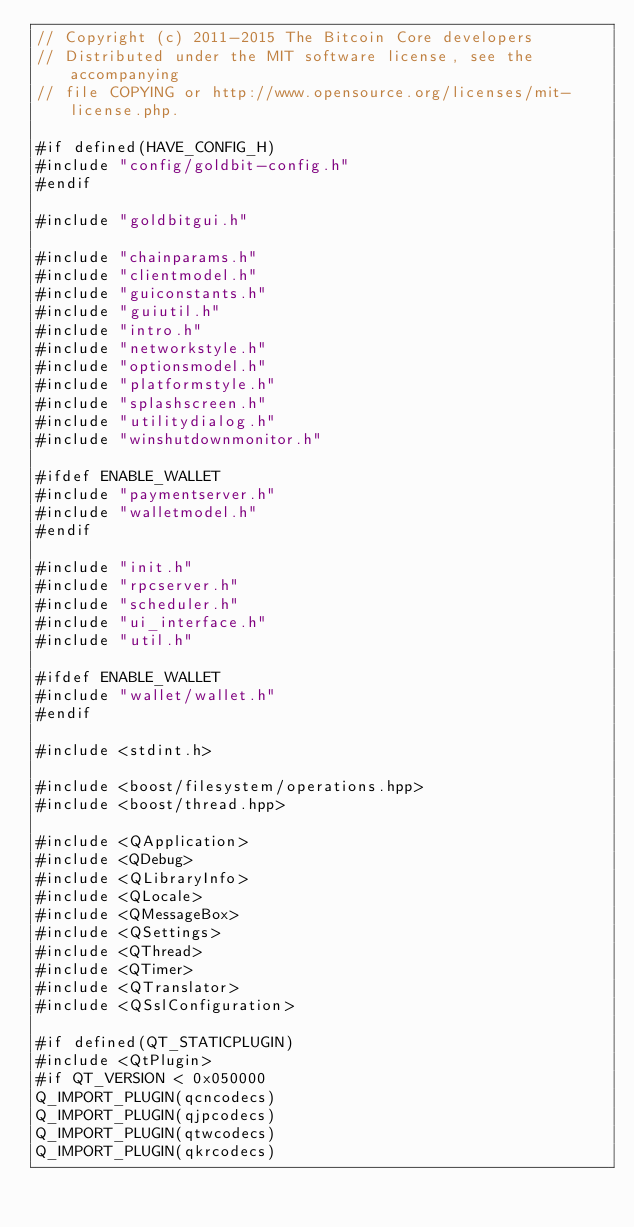<code> <loc_0><loc_0><loc_500><loc_500><_C++_>// Copyright (c) 2011-2015 The Bitcoin Core developers
// Distributed under the MIT software license, see the accompanying
// file COPYING or http://www.opensource.org/licenses/mit-license.php.

#if defined(HAVE_CONFIG_H)
#include "config/goldbit-config.h"
#endif

#include "goldbitgui.h"

#include "chainparams.h"
#include "clientmodel.h"
#include "guiconstants.h"
#include "guiutil.h"
#include "intro.h"
#include "networkstyle.h"
#include "optionsmodel.h"
#include "platformstyle.h"
#include "splashscreen.h"
#include "utilitydialog.h"
#include "winshutdownmonitor.h"

#ifdef ENABLE_WALLET
#include "paymentserver.h"
#include "walletmodel.h"
#endif

#include "init.h"
#include "rpcserver.h"
#include "scheduler.h"
#include "ui_interface.h"
#include "util.h"

#ifdef ENABLE_WALLET
#include "wallet/wallet.h"
#endif

#include <stdint.h>

#include <boost/filesystem/operations.hpp>
#include <boost/thread.hpp>

#include <QApplication>
#include <QDebug>
#include <QLibraryInfo>
#include <QLocale>
#include <QMessageBox>
#include <QSettings>
#include <QThread>
#include <QTimer>
#include <QTranslator>
#include <QSslConfiguration>

#if defined(QT_STATICPLUGIN)
#include <QtPlugin>
#if QT_VERSION < 0x050000
Q_IMPORT_PLUGIN(qcncodecs)
Q_IMPORT_PLUGIN(qjpcodecs)
Q_IMPORT_PLUGIN(qtwcodecs)
Q_IMPORT_PLUGIN(qkrcodecs)</code> 